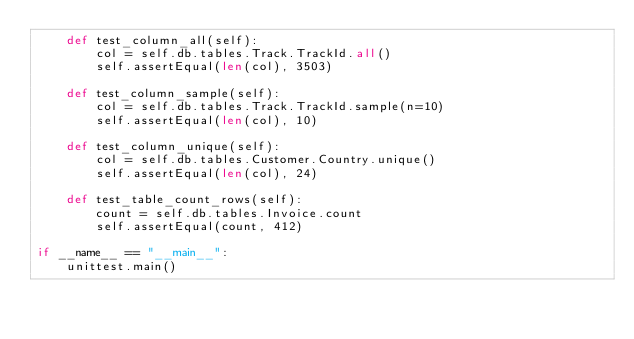Convert code to text. <code><loc_0><loc_0><loc_500><loc_500><_Python_>    def test_column_all(self):
        col = self.db.tables.Track.TrackId.all()
        self.assertEqual(len(col), 3503)

    def test_column_sample(self):
        col = self.db.tables.Track.TrackId.sample(n=10)
        self.assertEqual(len(col), 10)

    def test_column_unique(self):
        col = self.db.tables.Customer.Country.unique()
        self.assertEqual(len(col), 24)

    def test_table_count_rows(self):
        count = self.db.tables.Invoice.count
        self.assertEqual(count, 412)

if __name__ == "__main__":
    unittest.main()
</code> 